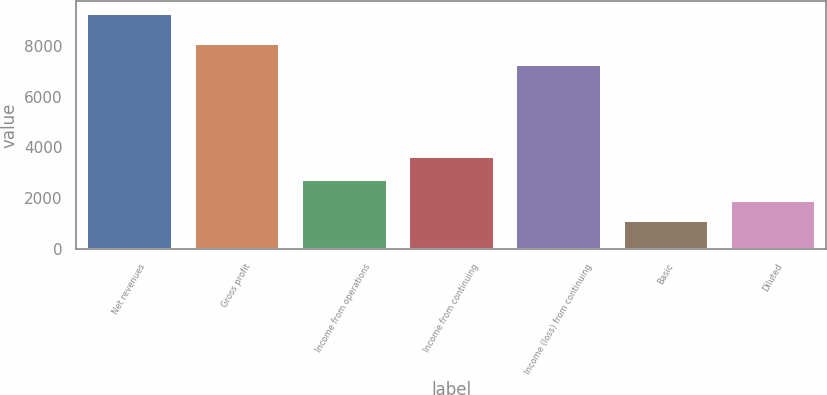<chart> <loc_0><loc_0><loc_500><loc_500><bar_chart><fcel>Net revenues<fcel>Gross profit<fcel>Income from operations<fcel>Income from continuing<fcel>Income (loss) from continuing<fcel>Basic<fcel>Diluted<nl><fcel>9298<fcel>8101.5<fcel>2766<fcel>3651<fcel>7285<fcel>1133<fcel>1949.5<nl></chart> 